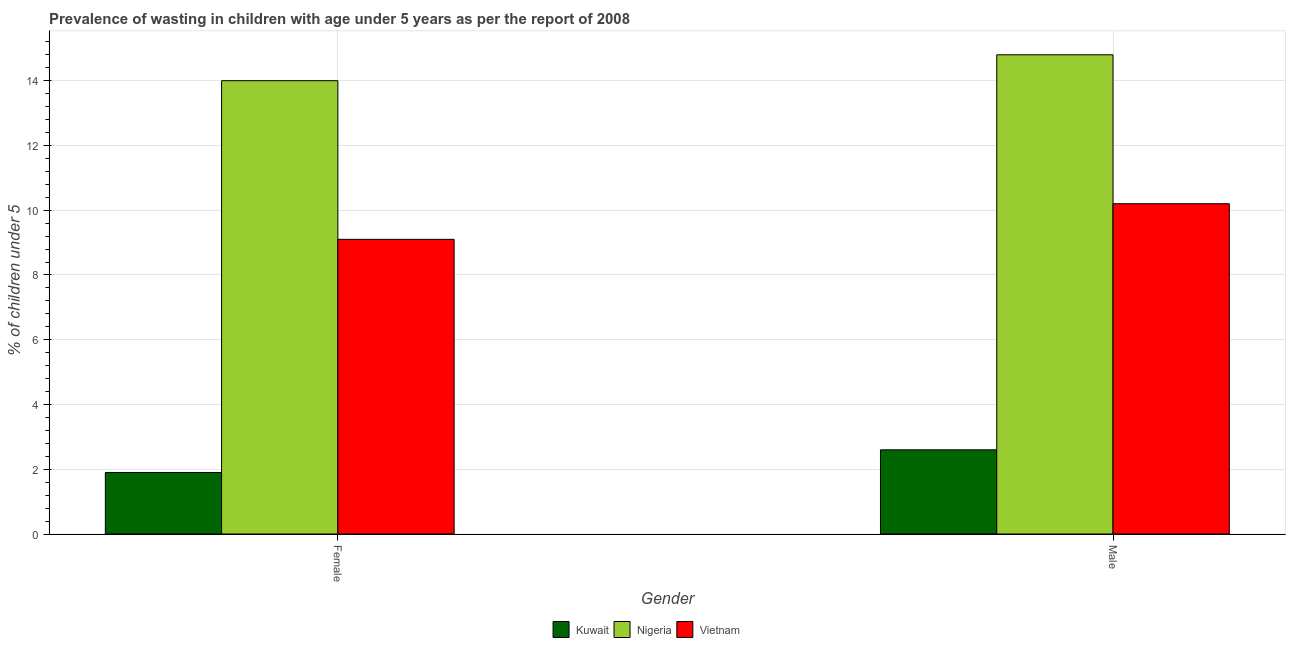How many groups of bars are there?
Give a very brief answer. 2. What is the label of the 2nd group of bars from the left?
Give a very brief answer. Male. What is the percentage of undernourished female children in Vietnam?
Give a very brief answer. 9.1. Across all countries, what is the minimum percentage of undernourished male children?
Keep it short and to the point. 2.6. In which country was the percentage of undernourished female children maximum?
Ensure brevity in your answer.  Nigeria. In which country was the percentage of undernourished female children minimum?
Make the answer very short. Kuwait. What is the total percentage of undernourished male children in the graph?
Provide a succinct answer. 27.6. What is the difference between the percentage of undernourished male children in Kuwait and that in Nigeria?
Ensure brevity in your answer.  -12.2. What is the difference between the percentage of undernourished male children in Kuwait and the percentage of undernourished female children in Nigeria?
Offer a very short reply. -11.4. What is the average percentage of undernourished female children per country?
Give a very brief answer. 8.33. What is the difference between the percentage of undernourished female children and percentage of undernourished male children in Vietnam?
Provide a succinct answer. -1.1. In how many countries, is the percentage of undernourished female children greater than 6 %?
Your answer should be very brief. 2. What is the ratio of the percentage of undernourished male children in Vietnam to that in Nigeria?
Offer a very short reply. 0.69. Is the percentage of undernourished male children in Kuwait less than that in Vietnam?
Give a very brief answer. Yes. What does the 3rd bar from the left in Male represents?
Provide a short and direct response. Vietnam. What does the 3rd bar from the right in Female represents?
Provide a succinct answer. Kuwait. How many bars are there?
Ensure brevity in your answer.  6. What is the difference between two consecutive major ticks on the Y-axis?
Provide a succinct answer. 2. Does the graph contain any zero values?
Give a very brief answer. No. How many legend labels are there?
Ensure brevity in your answer.  3. What is the title of the graph?
Provide a succinct answer. Prevalence of wasting in children with age under 5 years as per the report of 2008. What is the label or title of the X-axis?
Keep it short and to the point. Gender. What is the label or title of the Y-axis?
Your response must be concise.  % of children under 5. What is the  % of children under 5 in Kuwait in Female?
Your answer should be compact. 1.9. What is the  % of children under 5 of Nigeria in Female?
Offer a terse response. 14. What is the  % of children under 5 of Vietnam in Female?
Provide a succinct answer. 9.1. What is the  % of children under 5 in Kuwait in Male?
Provide a succinct answer. 2.6. What is the  % of children under 5 of Nigeria in Male?
Ensure brevity in your answer.  14.8. What is the  % of children under 5 of Vietnam in Male?
Give a very brief answer. 10.2. Across all Gender, what is the maximum  % of children under 5 in Kuwait?
Your answer should be compact. 2.6. Across all Gender, what is the maximum  % of children under 5 in Nigeria?
Your answer should be compact. 14.8. Across all Gender, what is the maximum  % of children under 5 of Vietnam?
Your answer should be compact. 10.2. Across all Gender, what is the minimum  % of children under 5 of Kuwait?
Ensure brevity in your answer.  1.9. Across all Gender, what is the minimum  % of children under 5 in Vietnam?
Provide a short and direct response. 9.1. What is the total  % of children under 5 of Kuwait in the graph?
Your response must be concise. 4.5. What is the total  % of children under 5 of Nigeria in the graph?
Provide a short and direct response. 28.8. What is the total  % of children under 5 of Vietnam in the graph?
Give a very brief answer. 19.3. What is the difference between the  % of children under 5 in Vietnam in Female and that in Male?
Give a very brief answer. -1.1. What is the difference between the  % of children under 5 of Kuwait in Female and the  % of children under 5 of Nigeria in Male?
Your answer should be compact. -12.9. What is the average  % of children under 5 of Kuwait per Gender?
Provide a succinct answer. 2.25. What is the average  % of children under 5 of Vietnam per Gender?
Offer a very short reply. 9.65. What is the difference between the  % of children under 5 in Kuwait and  % of children under 5 in Nigeria in Male?
Give a very brief answer. -12.2. What is the difference between the  % of children under 5 of Kuwait and  % of children under 5 of Vietnam in Male?
Your answer should be very brief. -7.6. What is the ratio of the  % of children under 5 in Kuwait in Female to that in Male?
Ensure brevity in your answer.  0.73. What is the ratio of the  % of children under 5 of Nigeria in Female to that in Male?
Offer a very short reply. 0.95. What is the ratio of the  % of children under 5 of Vietnam in Female to that in Male?
Offer a terse response. 0.89. What is the difference between the highest and the second highest  % of children under 5 of Nigeria?
Your response must be concise. 0.8. What is the difference between the highest and the second highest  % of children under 5 of Vietnam?
Your answer should be very brief. 1.1. What is the difference between the highest and the lowest  % of children under 5 in Nigeria?
Ensure brevity in your answer.  0.8. What is the difference between the highest and the lowest  % of children under 5 of Vietnam?
Provide a succinct answer. 1.1. 